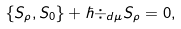<formula> <loc_0><loc_0><loc_500><loc_500>\{ S _ { \rho } , S _ { 0 } \} + \hbar { \div } _ { d \mu } S _ { \rho } = 0 ,</formula> 